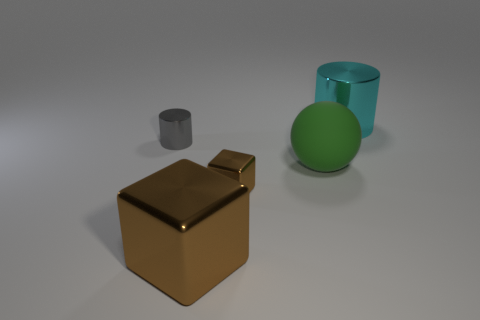Is there anything else that has the same material as the ball?
Offer a very short reply. No. Are there any brown objects in front of the tiny object in front of the large sphere?
Make the answer very short. Yes. Does the big thing right of the large green ball have the same shape as the big shiny thing that is to the left of the large cyan shiny object?
Keep it short and to the point. No. Are the tiny thing that is in front of the small gray object and the large object in front of the small metallic block made of the same material?
Offer a very short reply. Yes. There is a cylinder that is to the right of the shiny cylinder that is left of the matte ball; what is it made of?
Make the answer very short. Metal. The big object behind the shiny cylinder that is left of the large thing that is behind the tiny shiny cylinder is what shape?
Keep it short and to the point. Cylinder. There is a big cyan thing that is the same shape as the small gray thing; what material is it?
Make the answer very short. Metal. How many gray cylinders are there?
Make the answer very short. 1. What shape is the large metal thing that is right of the big brown shiny cube?
Keep it short and to the point. Cylinder. There is a tiny shiny object on the left side of the tiny shiny thing that is in front of the tiny thing behind the green ball; what color is it?
Your answer should be very brief. Gray. 